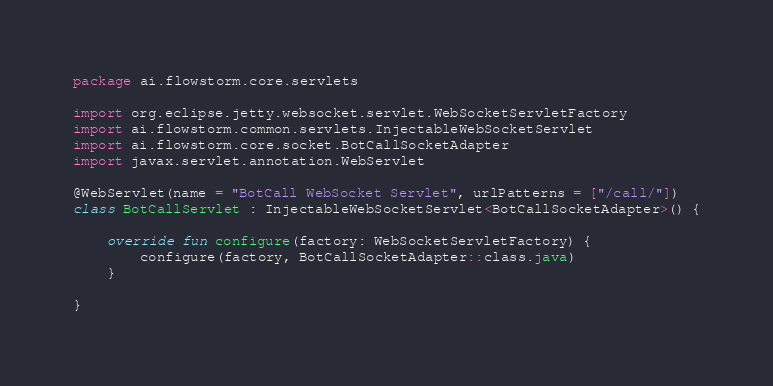Convert code to text. <code><loc_0><loc_0><loc_500><loc_500><_Kotlin_>package ai.flowstorm.core.servlets

import org.eclipse.jetty.websocket.servlet.WebSocketServletFactory
import ai.flowstorm.common.servlets.InjectableWebSocketServlet
import ai.flowstorm.core.socket.BotCallSocketAdapter
import javax.servlet.annotation.WebServlet

@WebServlet(name = "BotCall WebSocket Servlet", urlPatterns = ["/call/"])
class BotCallServlet : InjectableWebSocketServlet<BotCallSocketAdapter>() {

    override fun configure(factory: WebSocketServletFactory) {
        configure(factory, BotCallSocketAdapter::class.java)
    }

}</code> 